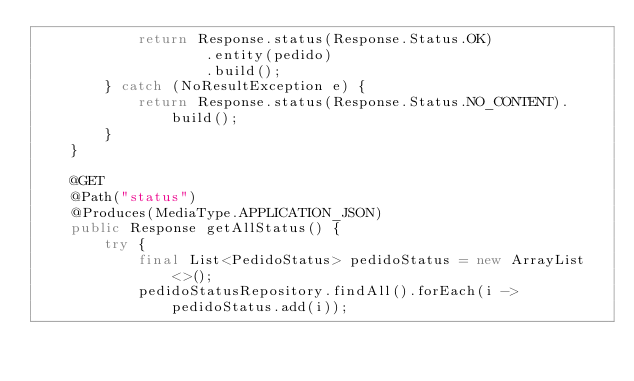<code> <loc_0><loc_0><loc_500><loc_500><_Java_>            return Response.status(Response.Status.OK)
                    .entity(pedido)
                    .build();
        } catch (NoResultException e) {
            return Response.status(Response.Status.NO_CONTENT).build();
        }
    }

    @GET
    @Path("status")
    @Produces(MediaType.APPLICATION_JSON)
    public Response getAllStatus() {
        try {
            final List<PedidoStatus> pedidoStatus = new ArrayList<>();
            pedidoStatusRepository.findAll().forEach(i -> pedidoStatus.add(i));
</code> 